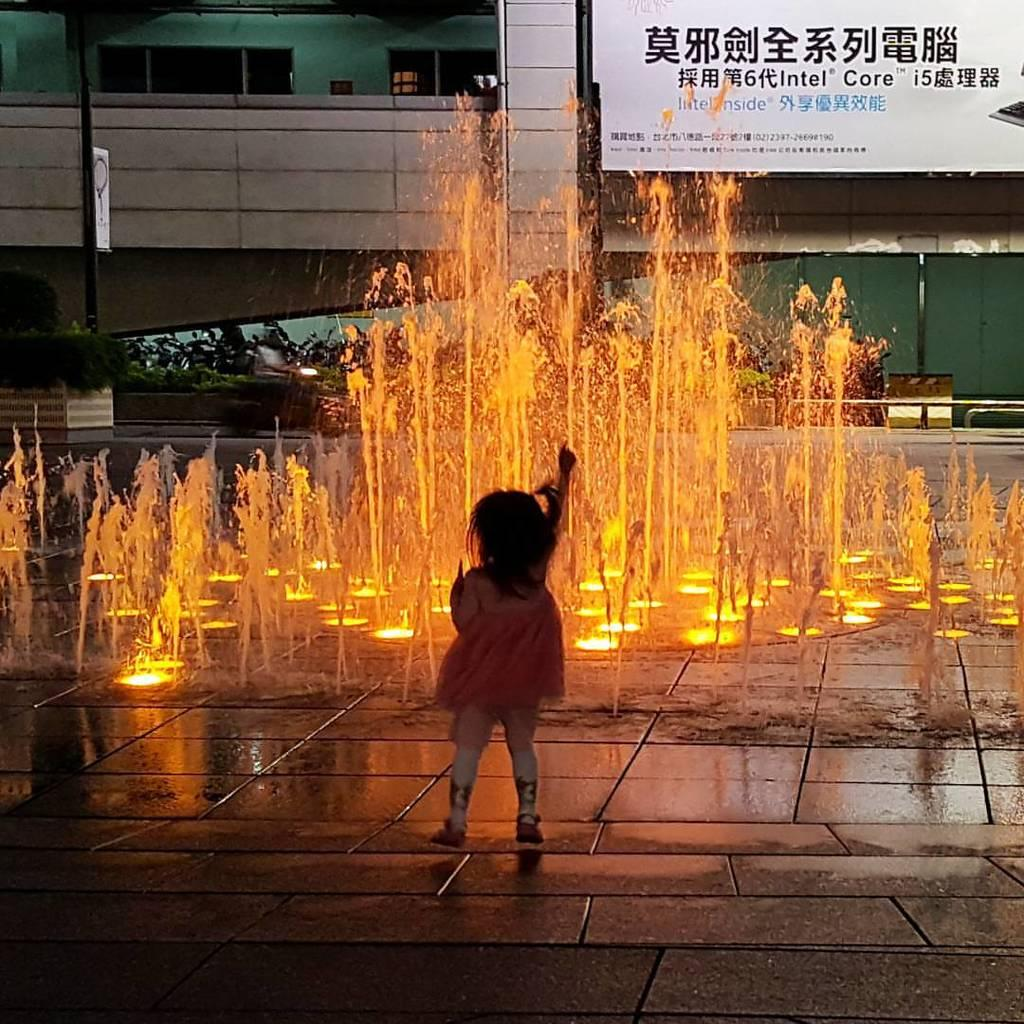Who is present in the image? There is a girl in the image. What can be seen in the foreground of the image? There is a water fountain in the image. What is visible in the background of the image? There is a hoarding, poles, a board, and plants in the background of the image. What type of power source is visible in the image? There is no power source visible in the image. How many bushes are present in the image? There are no bushes mentioned in the provided facts, so it cannot be determined from the image. 